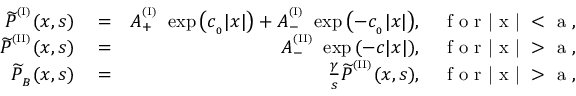<formula> <loc_0><loc_0><loc_500><loc_500>\begin{array} { r l r } { { \widetilde { P } } ^ { ^ { ( I ) } } ( x , s ) } & = } & { A _ { + } ^ { ^ { ( I ) } } \ \exp { \left ( c _ { _ { 0 } } | x | \right ) } + A _ { - } ^ { ^ { ( I ) } } \ \exp { \left ( - c _ { _ { 0 } } | x | \right ) } , \quad f o r | x | < a , } \\ { { \widetilde { P } } ^ { ^ { ( I I ) } } ( x , s ) } & = } & { A _ { - } ^ { ^ { ( I I ) } } \ \exp { \left ( - c | x | \right ) } , \quad f o r | x | > a , } \\ { { \widetilde { P } } _ { _ { B } } ( x , s ) } & = } & { \frac { \gamma } { s } { \widetilde { P } } ^ { ^ { ( I I ) } } ( x , s ) , \quad f o r | x | > a , } \end{array}</formula> 